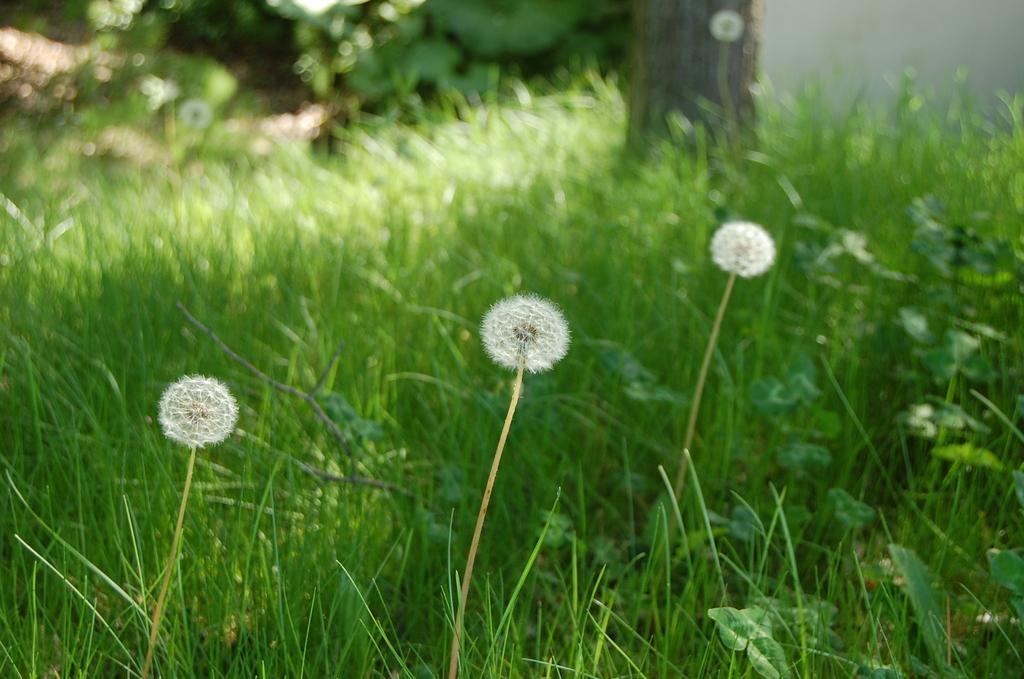In one or two sentences, can you explain what this image depicts? In the image,there is a green grass and in between the grass there are few blooms of the grass. 